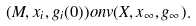Convert formula to latex. <formula><loc_0><loc_0><loc_500><loc_500>( M , x _ { i } , g _ { i } ( 0 ) ) o n v ( X , x _ { \infty } , g _ { \infty } ) .</formula> 